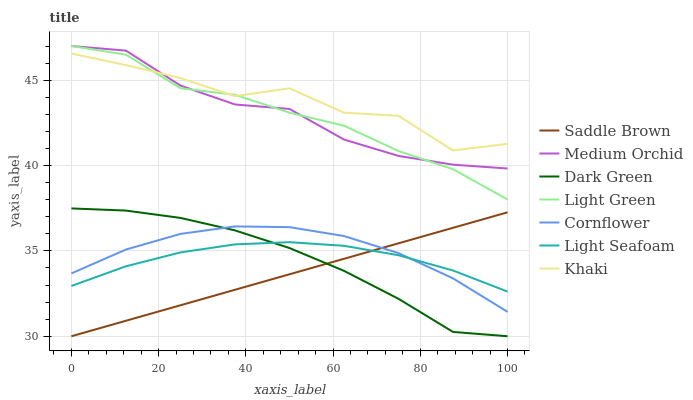Does Saddle Brown have the minimum area under the curve?
Answer yes or no. Yes. Does Khaki have the maximum area under the curve?
Answer yes or no. Yes. Does Medium Orchid have the minimum area under the curve?
Answer yes or no. No. Does Medium Orchid have the maximum area under the curve?
Answer yes or no. No. Is Saddle Brown the smoothest?
Answer yes or no. Yes. Is Khaki the roughest?
Answer yes or no. Yes. Is Medium Orchid the smoothest?
Answer yes or no. No. Is Medium Orchid the roughest?
Answer yes or no. No. Does Saddle Brown have the lowest value?
Answer yes or no. Yes. Does Medium Orchid have the lowest value?
Answer yes or no. No. Does Light Green have the highest value?
Answer yes or no. Yes. Does Khaki have the highest value?
Answer yes or no. No. Is Dark Green less than Khaki?
Answer yes or no. Yes. Is Medium Orchid greater than Light Seafoam?
Answer yes or no. Yes. Does Dark Green intersect Saddle Brown?
Answer yes or no. Yes. Is Dark Green less than Saddle Brown?
Answer yes or no. No. Is Dark Green greater than Saddle Brown?
Answer yes or no. No. Does Dark Green intersect Khaki?
Answer yes or no. No. 